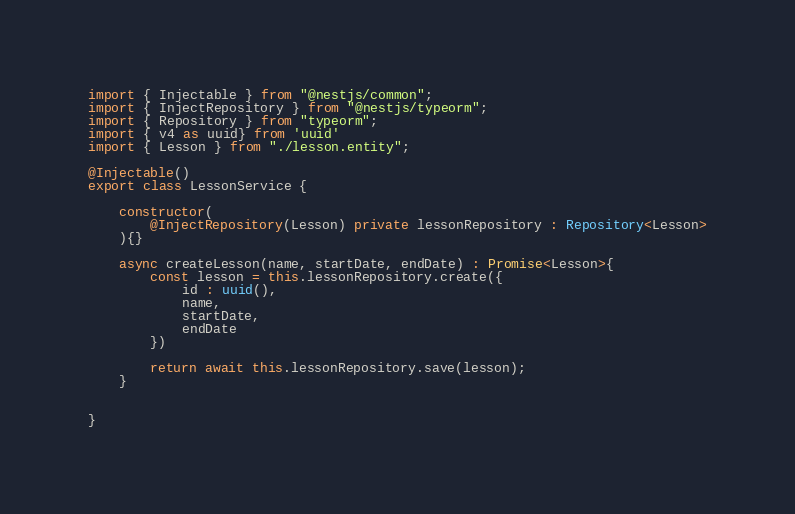<code> <loc_0><loc_0><loc_500><loc_500><_TypeScript_>import { Injectable } from "@nestjs/common";
import { InjectRepository } from "@nestjs/typeorm";
import { Repository } from "typeorm";
import { v4 as uuid} from 'uuid'
import { Lesson } from "./lesson.entity";

@Injectable()
export class LessonService {

    constructor(
        @InjectRepository(Lesson) private lessonRepository : Repository<Lesson>
    ){}

    async createLesson(name, startDate, endDate) : Promise<Lesson>{
        const lesson = this.lessonRepository.create({
            id : uuid(),
            name,
            startDate,
            endDate
        })

        return await this.lessonRepository.save(lesson);
    }
    

}</code> 